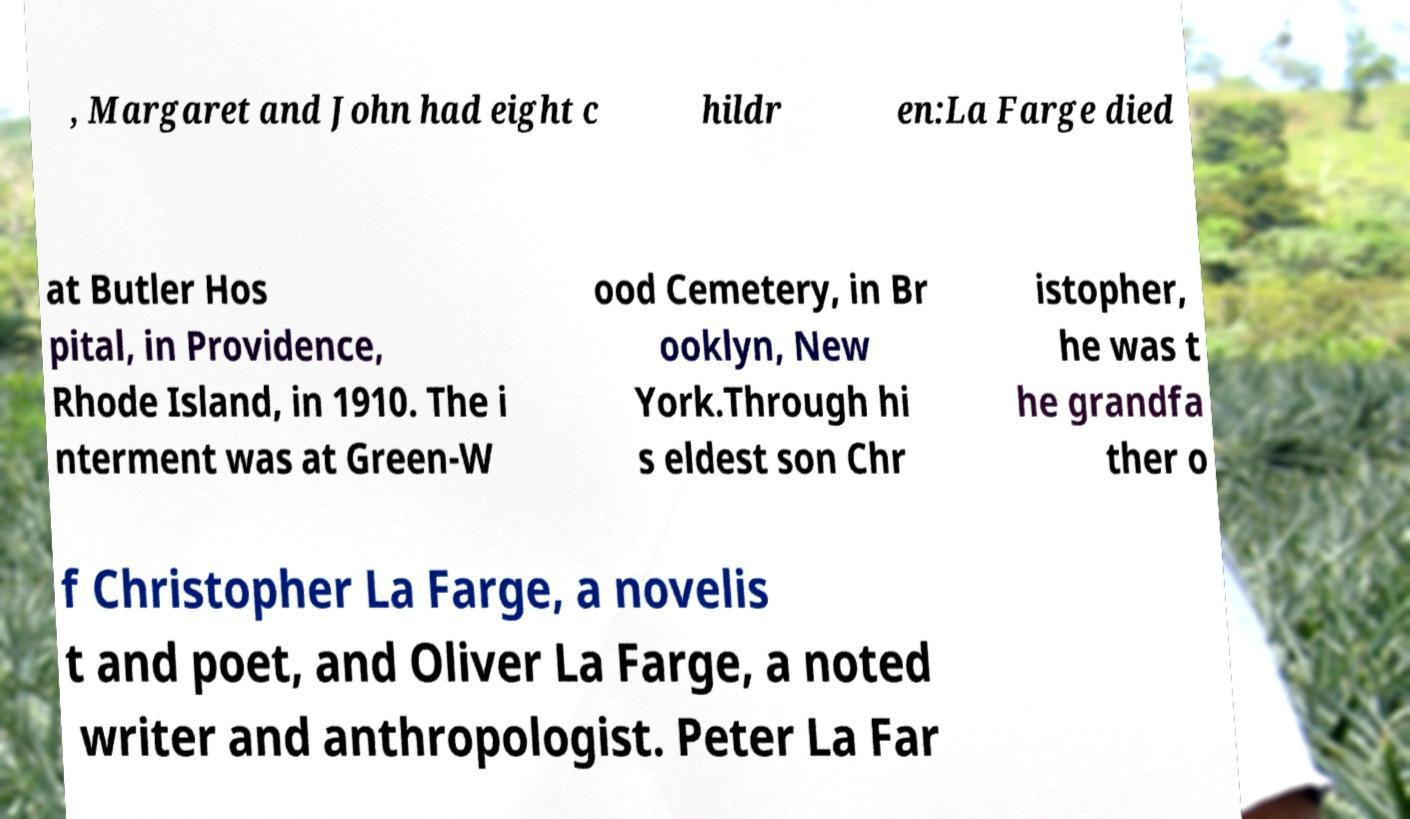I need the written content from this picture converted into text. Can you do that? , Margaret and John had eight c hildr en:La Farge died at Butler Hos pital, in Providence, Rhode Island, in 1910. The i nterment was at Green-W ood Cemetery, in Br ooklyn, New York.Through hi s eldest son Chr istopher, he was t he grandfa ther o f Christopher La Farge, a novelis t and poet, and Oliver La Farge, a noted writer and anthropologist. Peter La Far 